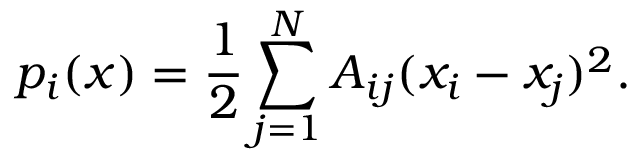<formula> <loc_0><loc_0><loc_500><loc_500>p _ { i } ( { \boldsymbol x } ) = \frac { 1 } { 2 } \sum _ { j = 1 } ^ { N } A _ { i j } ( x _ { i } - x _ { j } ) ^ { 2 } .</formula> 